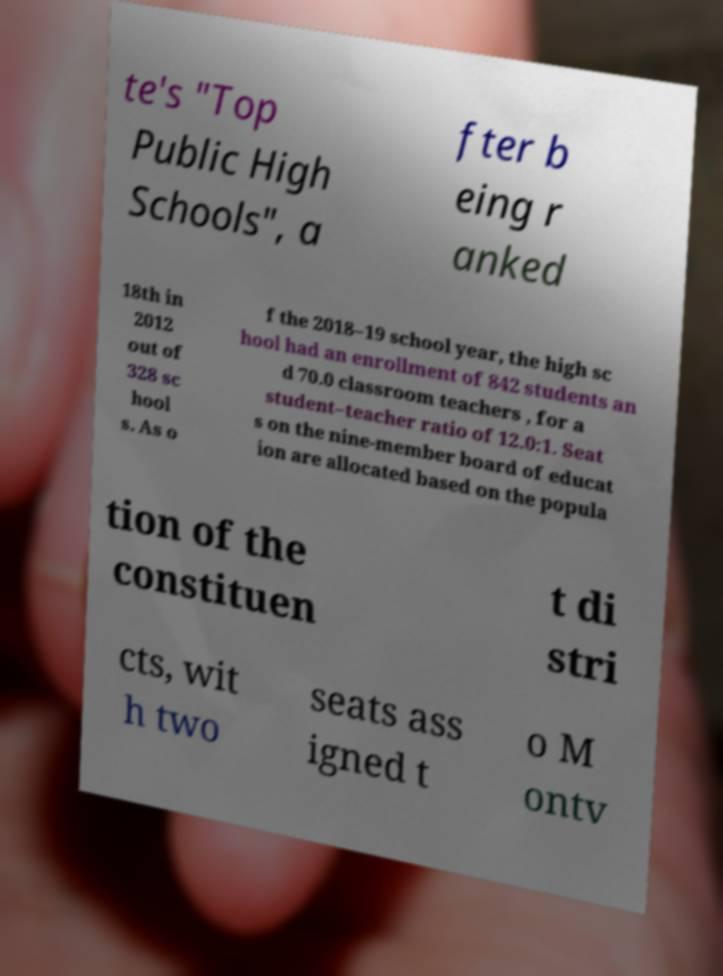Please read and relay the text visible in this image. What does it say? te's "Top Public High Schools", a fter b eing r anked 18th in 2012 out of 328 sc hool s. As o f the 2018–19 school year, the high sc hool had an enrollment of 842 students an d 70.0 classroom teachers , for a student–teacher ratio of 12.0:1. Seat s on the nine-member board of educat ion are allocated based on the popula tion of the constituen t di stri cts, wit h two seats ass igned t o M ontv 